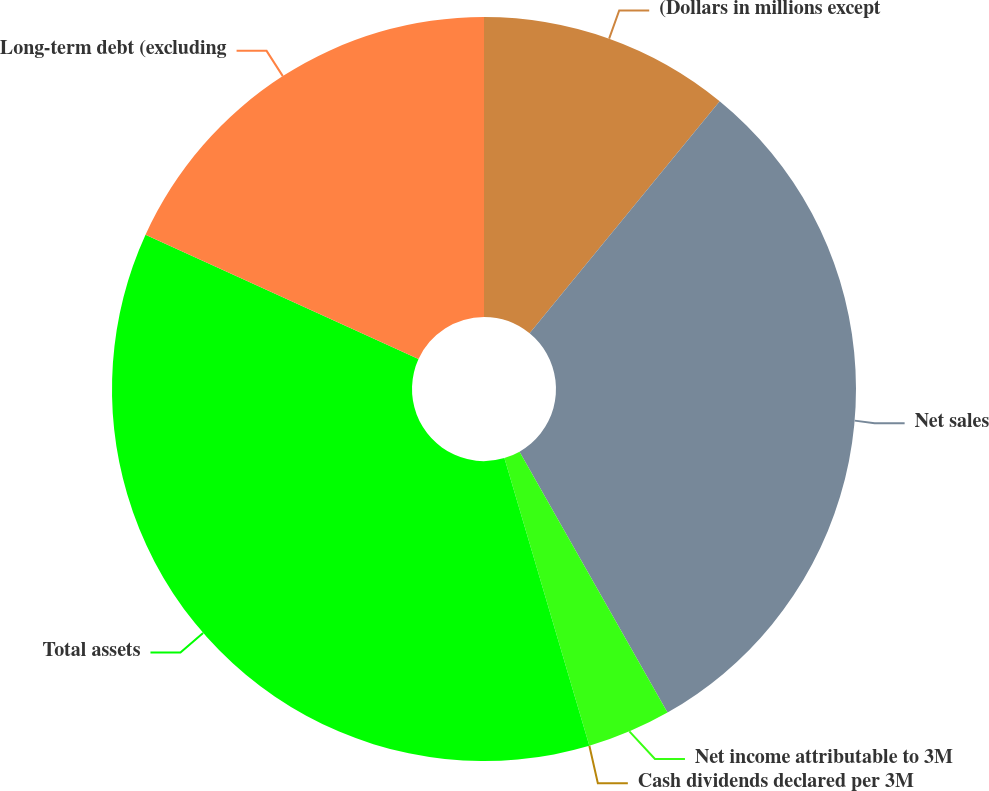<chart> <loc_0><loc_0><loc_500><loc_500><pie_chart><fcel>(Dollars in millions except<fcel>Net sales<fcel>Net income attributable to 3M<fcel>Cash dividends declared per 3M<fcel>Total assets<fcel>Long-term debt (excluding<nl><fcel>10.92%<fcel>30.87%<fcel>3.64%<fcel>0.0%<fcel>36.38%<fcel>18.19%<nl></chart> 